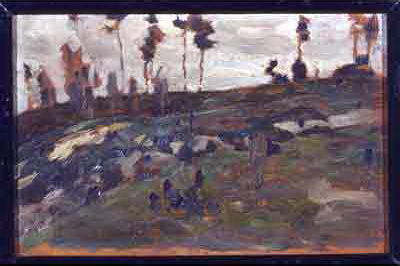Is there any sense of movement in this painting? Yes, the impressionist brushstrokes convey a subtle sense of movement in the painting. The trees appear to be swayed gently by a breeze, and the loose, flowing strokes add a dynamic quality to the depiction of the vegetation and rocky terrain. If this painting could produce sounds, what would they be? The painting would likely produce soft, rustling sounds of leaves and branches stirred by a gentle wind, accompanied by the distant call of birds. The subtle creaking of old trees and the quiet murmurs of nature would underscore the tranquil and reflective scene. Imagine the feeling of walking through this landscape. Walking through this landscape, one would feel a profound sense of serenity mixed with contemplation. The soft ground underfoot, the gentle whisper of the wind through the trees, and the muted, earthy colors would evoke a quiet reflection and connection with the timeless beauty of nature. The cool, fresh air might carry a hint of damp earth and the distant scent of foliage, adding to the meditative atmosphere. What if this scene was part of an ancient legend? In a forgotten legend, it was said that the hillside harbored the spirits of ancient guardians who watched over a hidden treasure buried beneath the rocks. The trees, once towering and majestic, were believed to sway and whisper secrets of the past winds to any who dared to climb the mystical terrain. Travelers who reached the crest of the hill under a full moon were granted a glimpse into the empire that once thrived in this now silent, solemn landscape. 